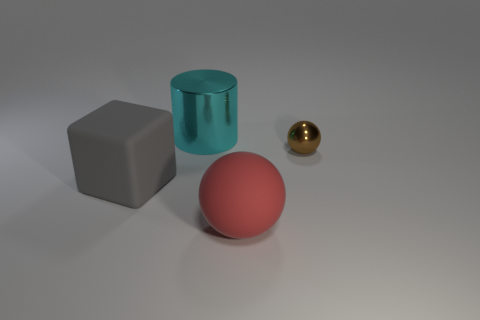Add 1 brown matte cylinders. How many objects exist? 5 Subtract all blocks. How many objects are left? 3 Subtract all big cubes. Subtract all gray matte things. How many objects are left? 2 Add 3 metal balls. How many metal balls are left? 4 Add 2 brown metallic objects. How many brown metallic objects exist? 3 Subtract 0 yellow spheres. How many objects are left? 4 